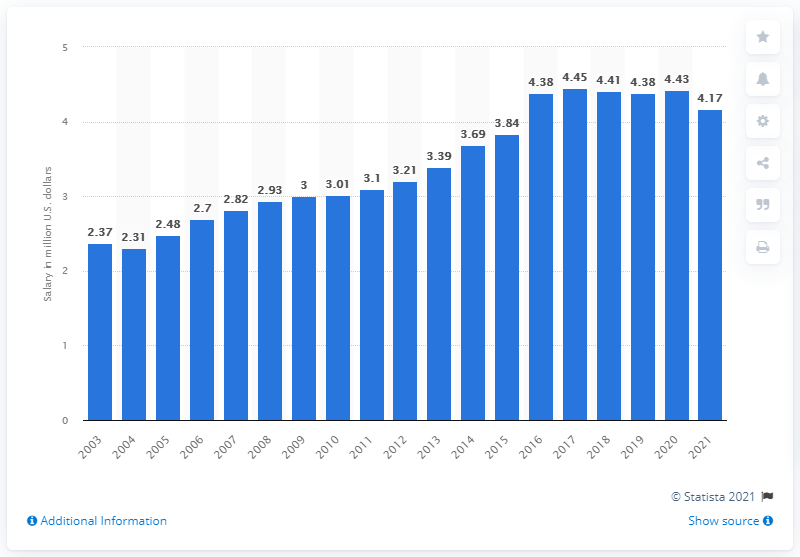Draw attention to some important aspects in this diagram. The average salary for a player in the MLB in 2021 was $4.17. 